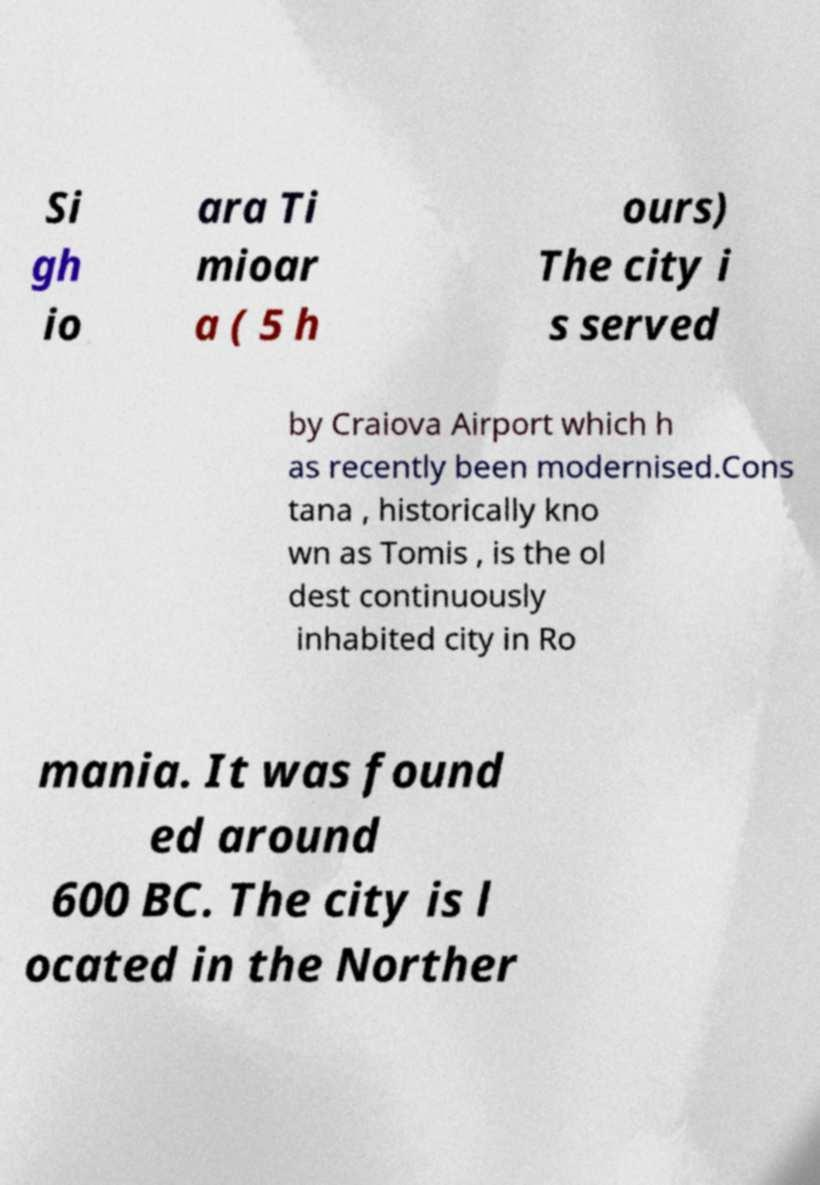There's text embedded in this image that I need extracted. Can you transcribe it verbatim? Si gh io ara Ti mioar a ( 5 h ours) The city i s served by Craiova Airport which h as recently been modernised.Cons tana , historically kno wn as Tomis , is the ol dest continuously inhabited city in Ro mania. It was found ed around 600 BC. The city is l ocated in the Norther 